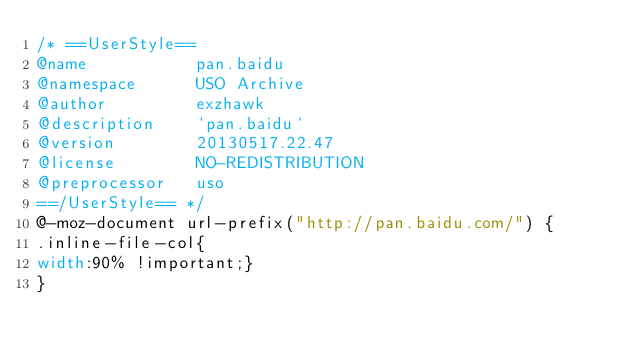<code> <loc_0><loc_0><loc_500><loc_500><_CSS_>/* ==UserStyle==
@name           pan.baidu
@namespace      USO Archive
@author         exzhawk
@description    `pan.baidu`
@version        20130517.22.47
@license        NO-REDISTRIBUTION
@preprocessor   uso
==/UserStyle== */
@-moz-document url-prefix("http://pan.baidu.com/") {
.inline-file-col{
width:90% !important;}
}</code> 